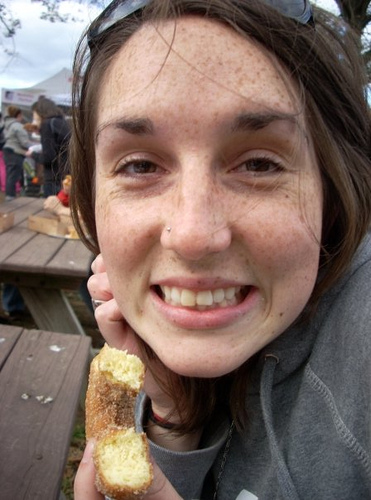How many dining tables are in the picture? The question refers to dining tables, but from the provided image, it's not possible to make out any dining tables as we only see a person holding food with no clear view of dining tables. 